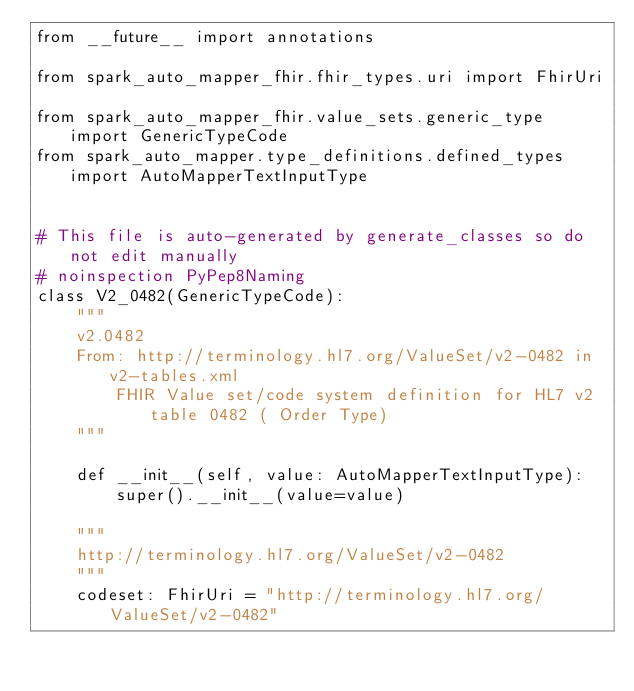<code> <loc_0><loc_0><loc_500><loc_500><_Python_>from __future__ import annotations

from spark_auto_mapper_fhir.fhir_types.uri import FhirUri

from spark_auto_mapper_fhir.value_sets.generic_type import GenericTypeCode
from spark_auto_mapper.type_definitions.defined_types import AutoMapperTextInputType


# This file is auto-generated by generate_classes so do not edit manually
# noinspection PyPep8Naming
class V2_0482(GenericTypeCode):
    """
    v2.0482
    From: http://terminology.hl7.org/ValueSet/v2-0482 in v2-tables.xml
        FHIR Value set/code system definition for HL7 v2 table 0482 ( Order Type)
    """

    def __init__(self, value: AutoMapperTextInputType):
        super().__init__(value=value)

    """
    http://terminology.hl7.org/ValueSet/v2-0482
    """
    codeset: FhirUri = "http://terminology.hl7.org/ValueSet/v2-0482"
</code> 